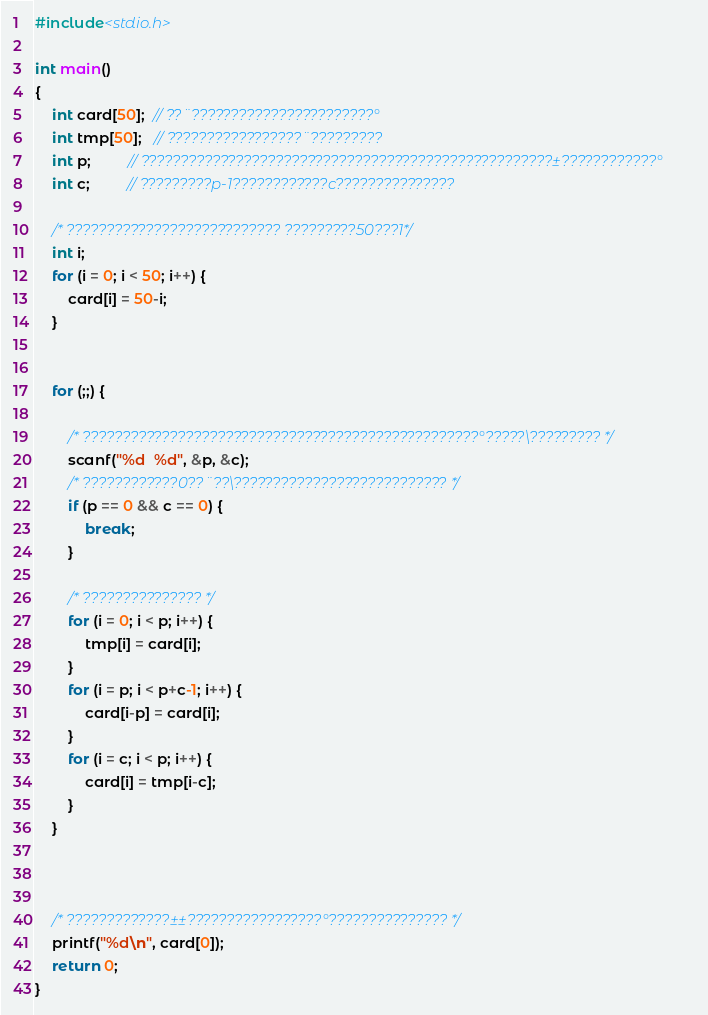<code> <loc_0><loc_0><loc_500><loc_500><_C_>
#include<stdio.h>

int main()
{
    int card[50];  // ??¨???????????????????????°
    int tmp[50];   // ?????????????????¨?????????
    int p;         // ????????????????????????????????????????????????????±????????????°
    int c;         // ?????????p-1????????????c???????????????
    
    /* ??????????????????????????? ?????????50???1*/
    int i;
    for (i = 0; i < 50; i++) {
        card[i] = 50-i;
    }
    
    
    for (;;) {
    
        /* ??????????????????????????????????????????????????°?????\????????? */
        scanf("%d  %d", &p, &c);
        /* ????????????0??¨??\??????????????????????????? */
        if (p == 0 && c == 0) {
            break;
        }
        
        /* ??????????????? */
        for (i = 0; i < p; i++) {
            tmp[i] = card[i];
        }
        for (i = p; i < p+c-1; i++) {
            card[i-p] = card[i];
        }
        for (i = c; i < p; i++) {
            card[i] = tmp[i-c];
        }
    }
    
    
    
    /* ?????????????±±?????????????????°??????????????? */
    printf("%d\n", card[0]);
    return 0;
}</code> 